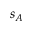<formula> <loc_0><loc_0><loc_500><loc_500>s _ { A }</formula> 